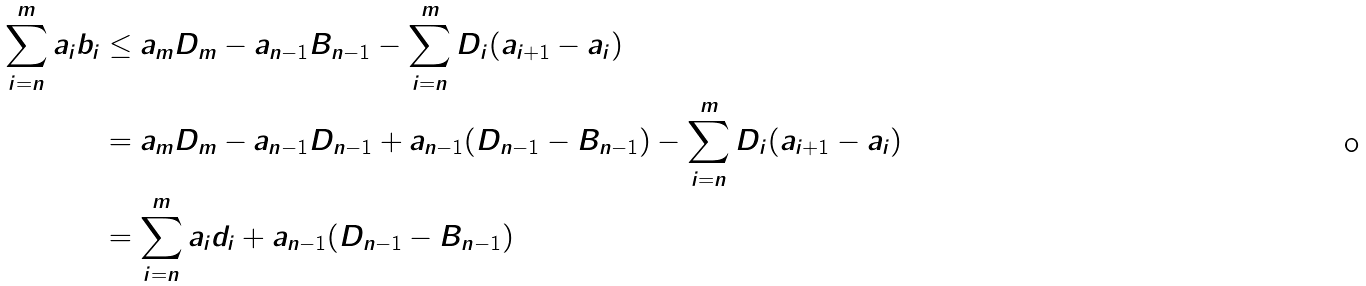<formula> <loc_0><loc_0><loc_500><loc_500>\sum _ { i = n } ^ { m } a _ { i } b _ { i } & \leq a _ { m } D _ { m } - a _ { n - 1 } B _ { n - 1 } - \sum _ { i = n } ^ { m } D _ { i } ( a _ { i + 1 } - a _ { i } ) \\ & = a _ { m } D _ { m } - a _ { n - 1 } D _ { n - 1 } + a _ { n - 1 } ( D _ { n - 1 } - B _ { n - 1 } ) - \sum _ { i = n } ^ { m } D _ { i } ( a _ { i + 1 } - a _ { i } ) \\ & = \sum _ { i = n } ^ { m } a _ { i } d _ { i } + a _ { n - 1 } ( D _ { n - 1 } - B _ { n - 1 } )</formula> 